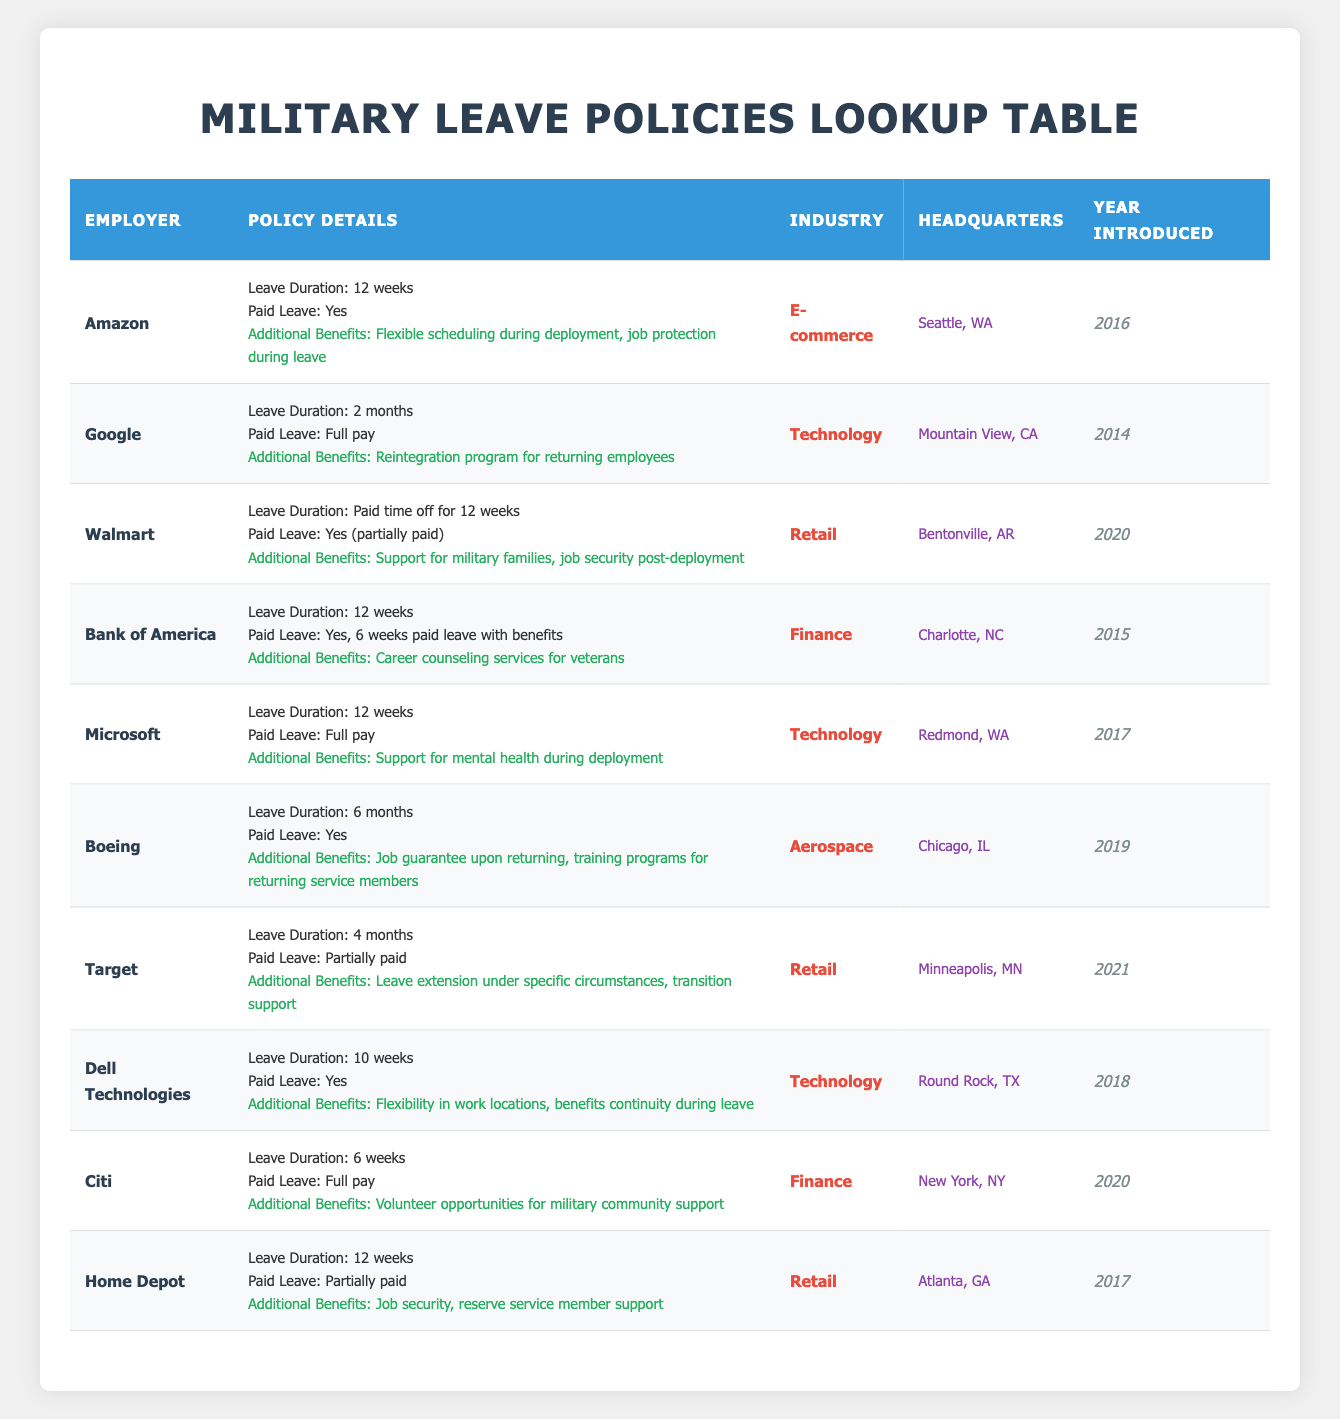What is the leave duration for Boeing? The table indicates that Boeing offers a leave duration of 6 months as specified in the “Leave Duration” column for Boeing’s entry.
Answer: 6 months Which employers provide full pay during military leave? The employers that provide full pay during military leave as per the “Paid Leave” column are Google, Microsoft, Citi, and Boeing.
Answer: Google, Microsoft, Citi How many employers offer 12 weeks of military leave? To find the number of employers offering 12 weeks of leave, we check the “Leave Duration” column and count the entries that state "12 weeks". The entries are Amazon, Bank of America, Walmart, and Home Depot. This gives us a total of 4 employers.
Answer: 4 Is Target's military leave partially paid? The table mentions that Target's military leave is listed as "Partially paid" in the “Paid Leave” column. Therefore, the answer is yes.
Answer: Yes Which industry has the most employers listed with a leave duration of 12 weeks? Checking the table’s entries for leave durations of 12 weeks, we find Amazon, Bank of America, Microsoft, and Home Depot are from the industries of E-commerce, Finance, and Technology. Therefore, the Retail industry has the most employers listed with 2 entries at 12 weeks.
Answer: Retail What is the difference in leave duration between the longest and shortest leave offered? The longest leave duration is 6 months offered by Boeing, and the shortest is 6 weeks offered by Citi. Converting 6 months to weeks gives 26 weeks (6 months × 4 weeks/month + 2 days). The difference is 26 weeks - 6 weeks = 20 weeks.
Answer: 20 weeks Do all employers who provide military leave offer additional benefits? By examining the "Additional Benefits" column, we see that every employer listed has some specified additional benefits, indicating that the answer is true.
Answer: Yes Which employer with the shortest leave duration is in the Finance industry? The shortest leave duration noted is 6 weeks for Citi, which falls under the Finance industry according to the "Industry" column.
Answer: Citi What year did Dell Technologies introduce its military leave policy? The "Year Introduced" column shows that Dell Technologies introduced its military leave policy in the year 2018.
Answer: 2018 How many employers have a leave duration longer than 3 months? We review the leave durations listed in the table. The employers with leave durations longer than 3 months are Boeing (6 months), Walmart (12 weeks), and Target (4 months), totaling 3 employers.
Answer: 3 